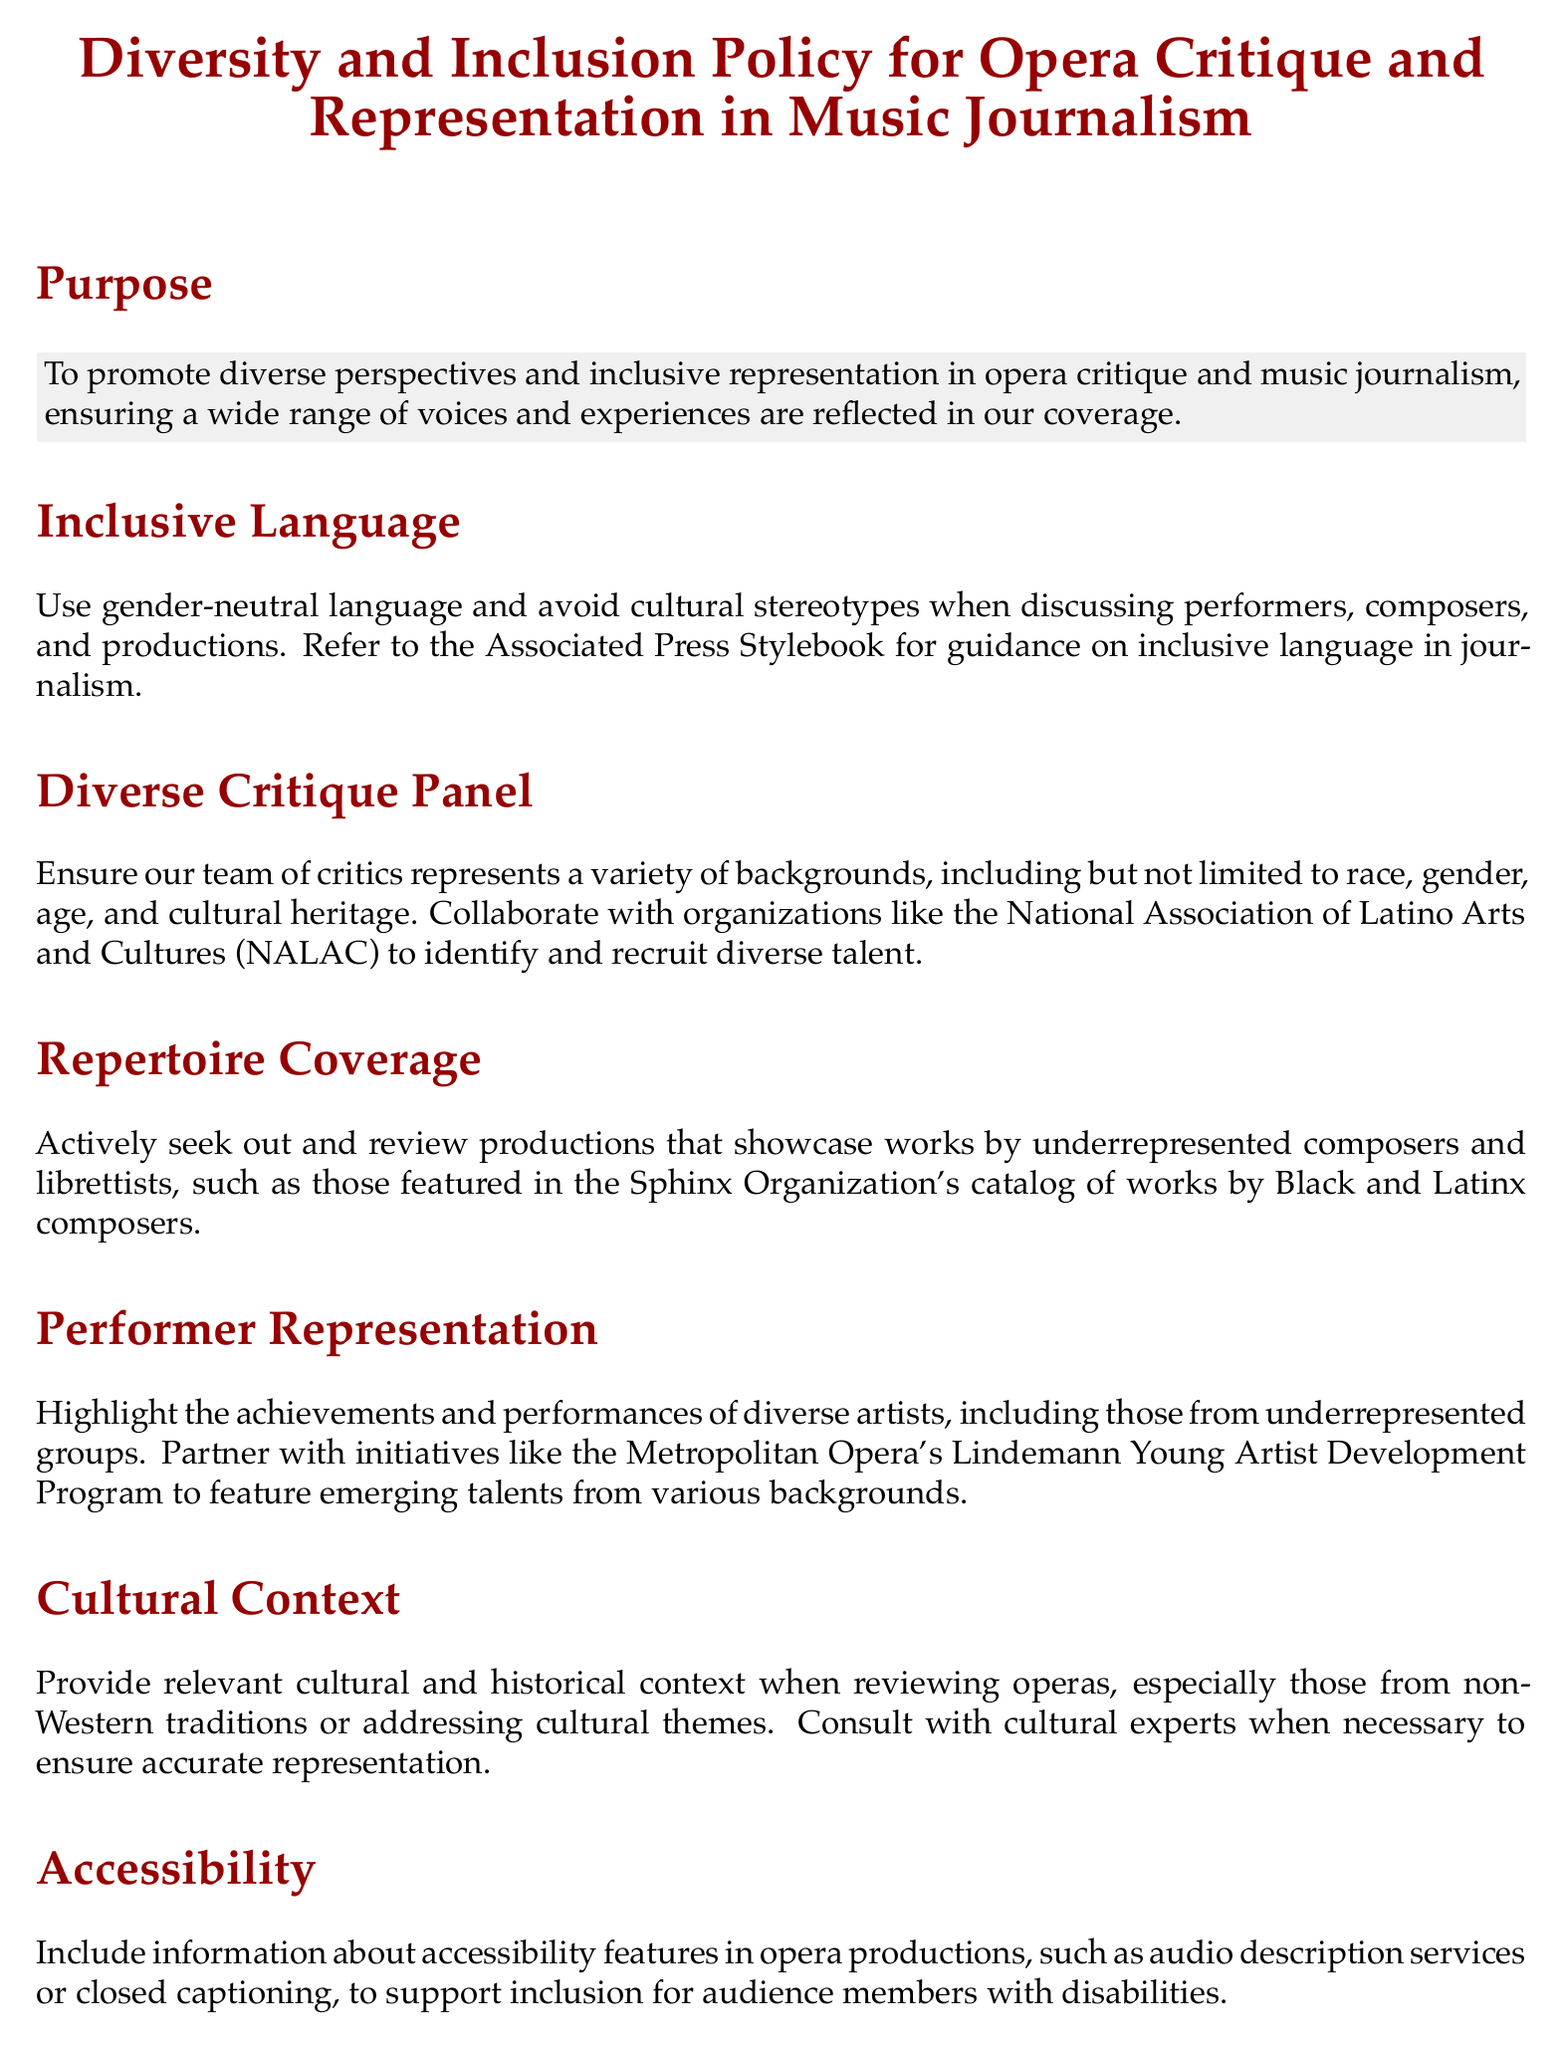What is the purpose of the policy? The purpose is to promote diverse perspectives and inclusive representation in opera critique and music journalism.
Answer: To promote diverse perspectives and inclusive representation in opera critique and music journalism What does the policy emphasize regarding language use? The policy emphasizes using gender-neutral language and avoiding cultural stereotypes.
Answer: Use gender-neutral language and avoid cultural stereotypes Which organization is mentioned for identifying and recruiting diverse talent? The policy mentions collaborating with the National Association of Latino Arts and Cultures.
Answer: National Association of Latino Arts and Cultures (NALAC) What is one of the objectives concerning repertoire coverage? The objective is to actively seek and review productions by underrepresented composers.
Answer: Review productions that showcase works by underrepresented composers How often will this policy be reviewed? The policy will be reviewed annually.
Answer: Annually What training does the policy suggest for music editors and critics? The policy suggests providing regular diversity and inclusion training.
Answer: Regular diversity and inclusion training What is mentioned as a resource for guidance on inclusive language? The Associated Press Stylebook is mentioned as a resource.
Answer: Associated Press Stylebook What accessibility features should be included according to the policy? The policy states to include information about audio description services and closed captioning.
Answer: Audio description services or closed captioning Which program does the policy suggest partnering with for highlighting diverse artists? The policy suggests partnering with the Metropolitan Opera's Lindemann Young Artist Development Program.
Answer: Metropolitan Opera's Lindemann Young Artist Development Program 